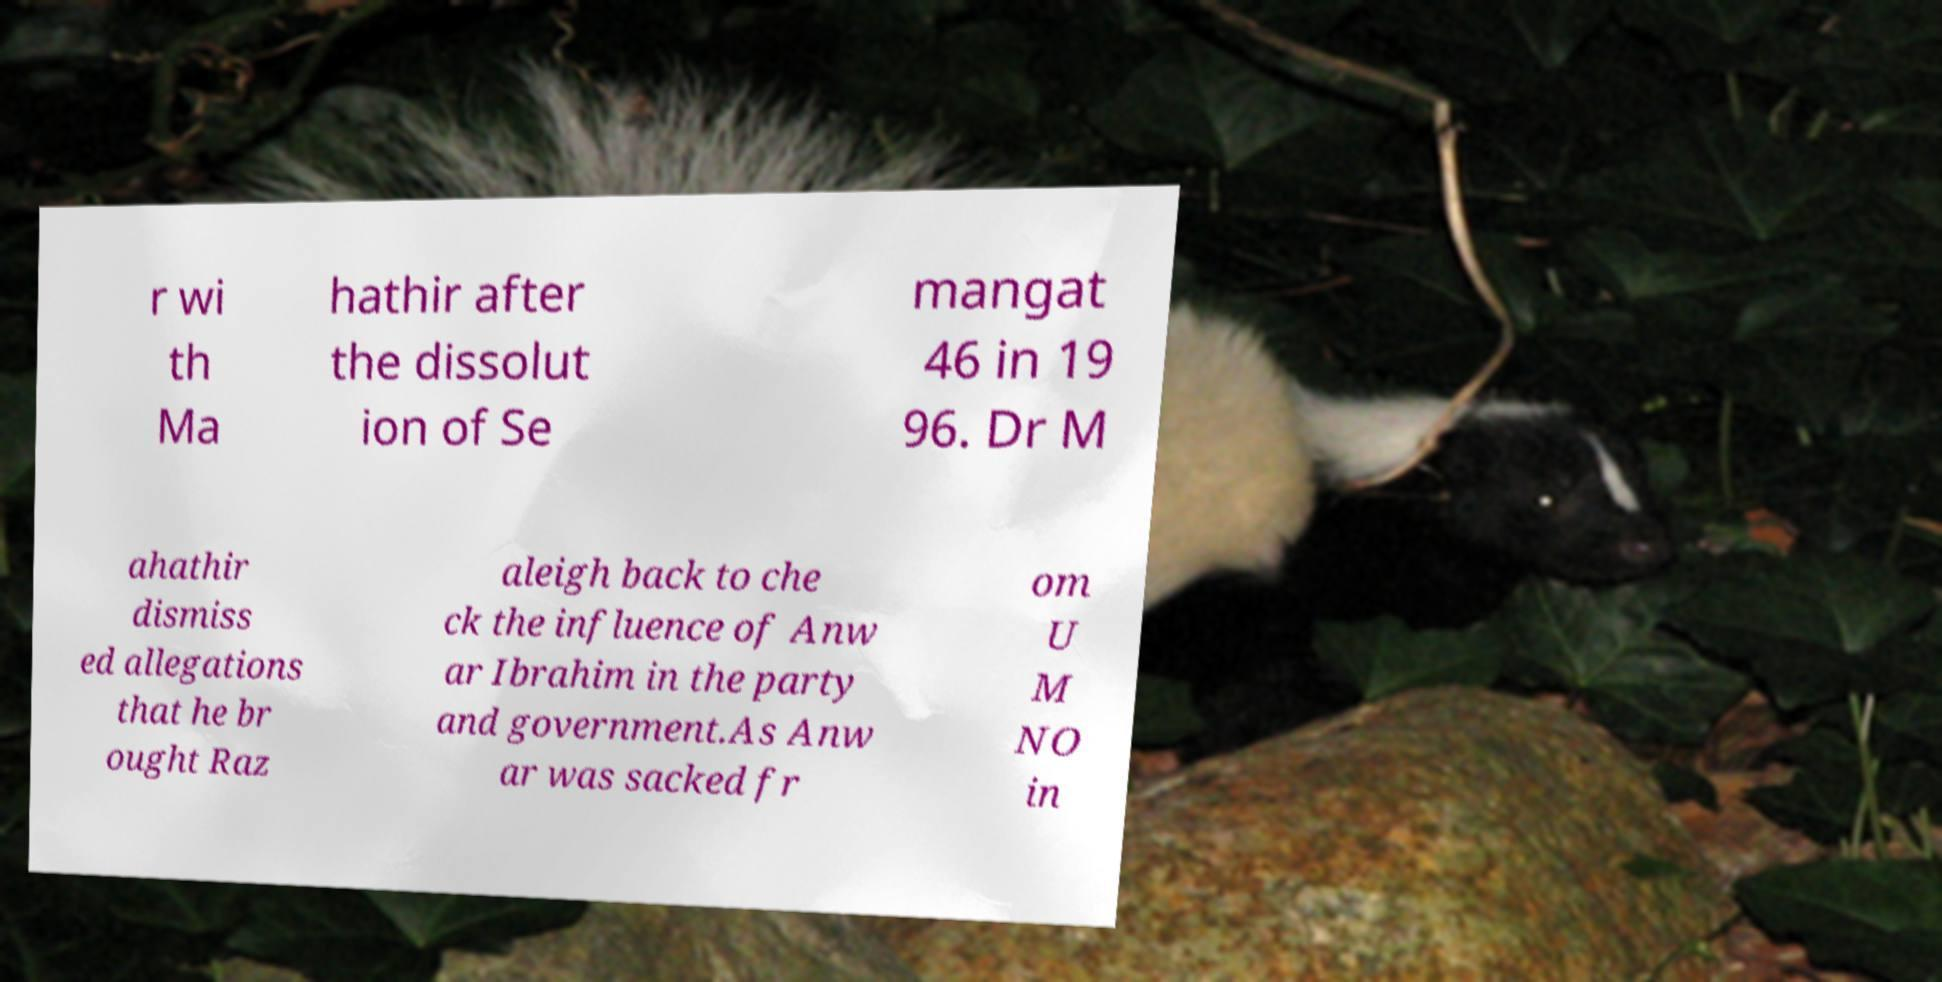There's text embedded in this image that I need extracted. Can you transcribe it verbatim? r wi th Ma hathir after the dissolut ion of Se mangat 46 in 19 96. Dr M ahathir dismiss ed allegations that he br ought Raz aleigh back to che ck the influence of Anw ar Ibrahim in the party and government.As Anw ar was sacked fr om U M NO in 